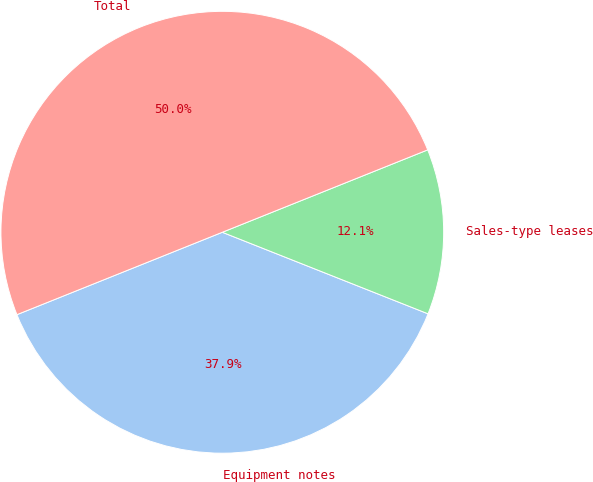<chart> <loc_0><loc_0><loc_500><loc_500><pie_chart><fcel>Equipment notes<fcel>Sales-type leases<fcel>Total<nl><fcel>37.9%<fcel>12.1%<fcel>50.0%<nl></chart> 